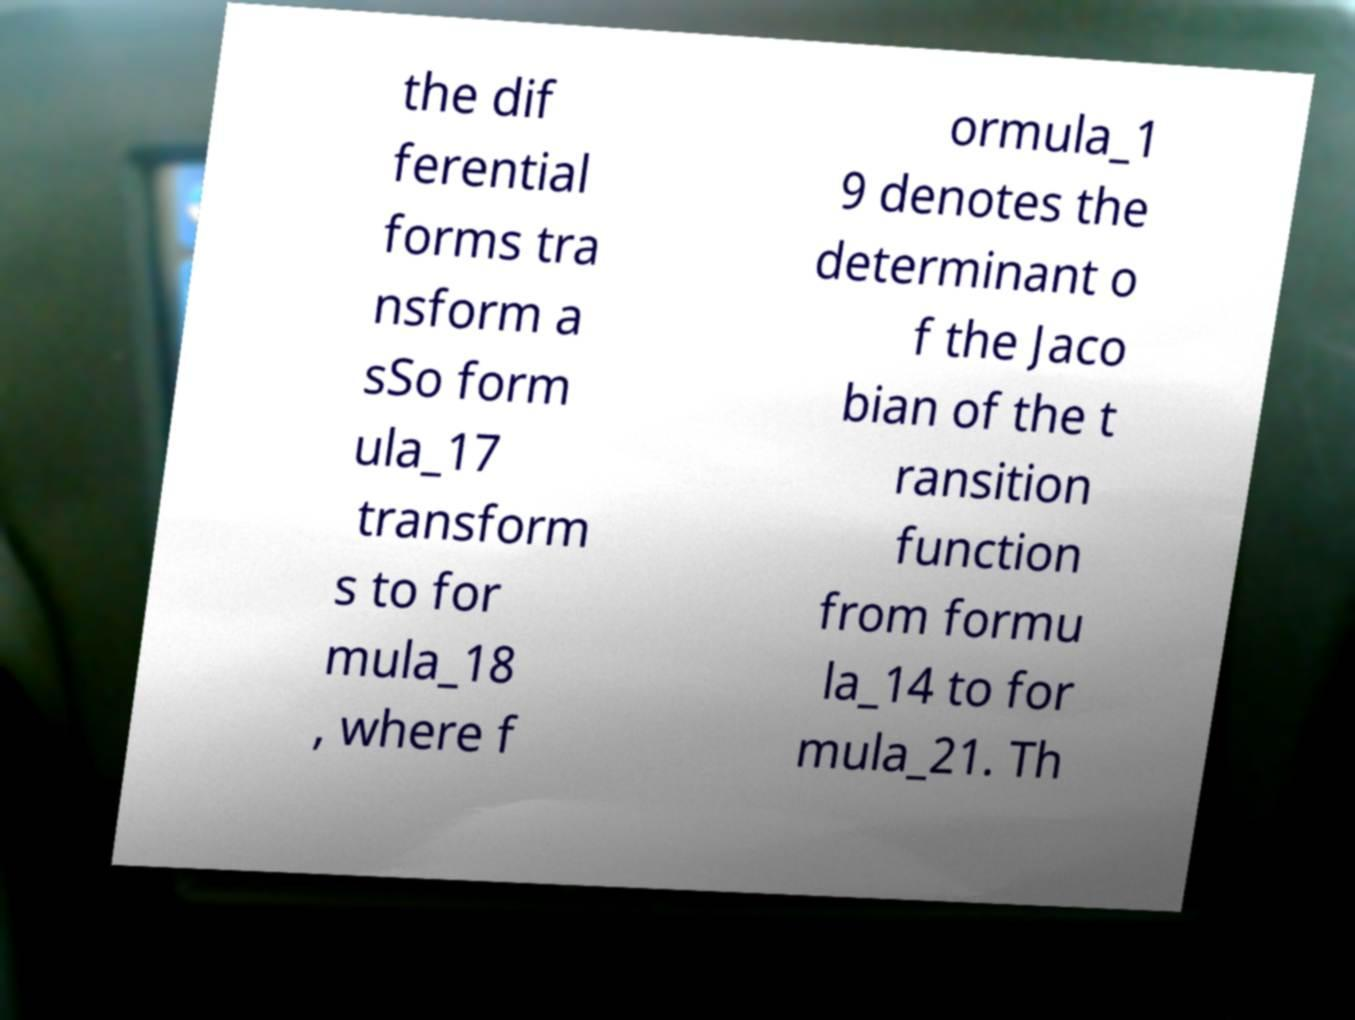Please identify and transcribe the text found in this image. the dif ferential forms tra nsform a sSo form ula_17 transform s to for mula_18 , where f ormula_1 9 denotes the determinant o f the Jaco bian of the t ransition function from formu la_14 to for mula_21. Th 